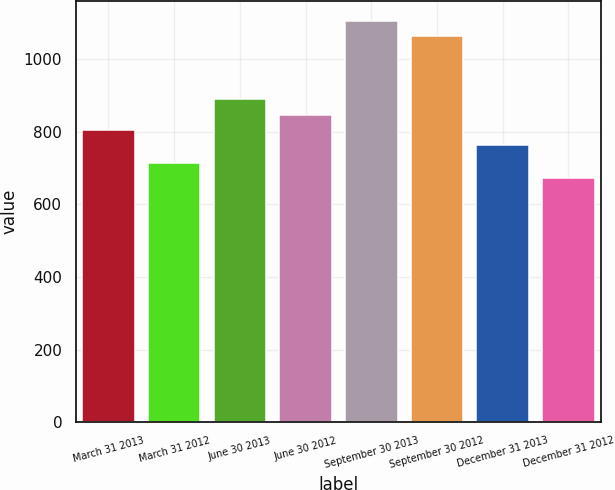<chart> <loc_0><loc_0><loc_500><loc_500><bar_chart><fcel>March 31 2013<fcel>March 31 2012<fcel>June 30 2013<fcel>June 30 2012<fcel>September 30 2013<fcel>September 30 2012<fcel>December 31 2013<fcel>December 31 2012<nl><fcel>805<fcel>715<fcel>889<fcel>847<fcel>1106<fcel>1064<fcel>763<fcel>673<nl></chart> 